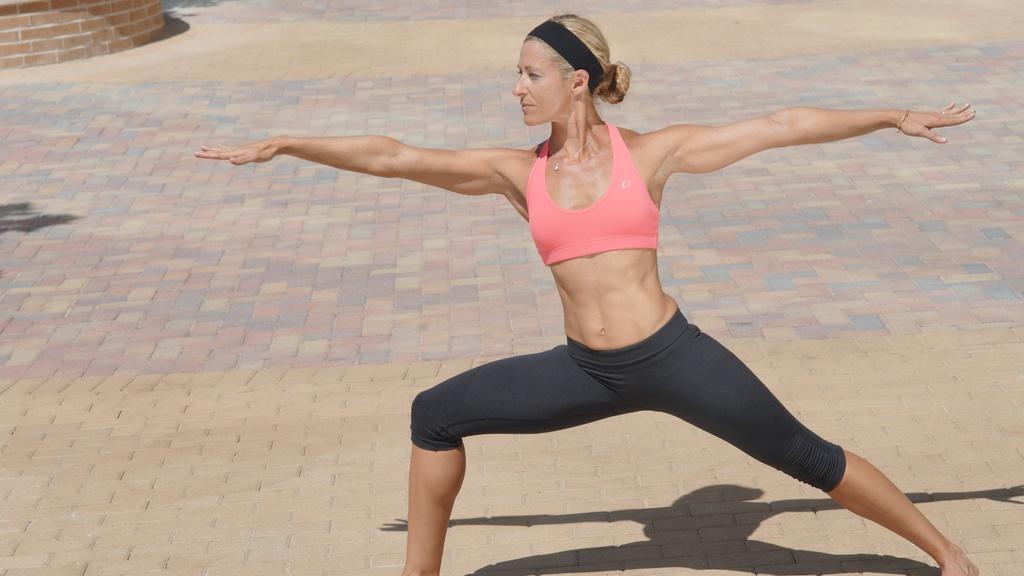Can you describe this image briefly? In the picture I can see a woman standing and stretching her body and there is a brick wall in the left top corner. 